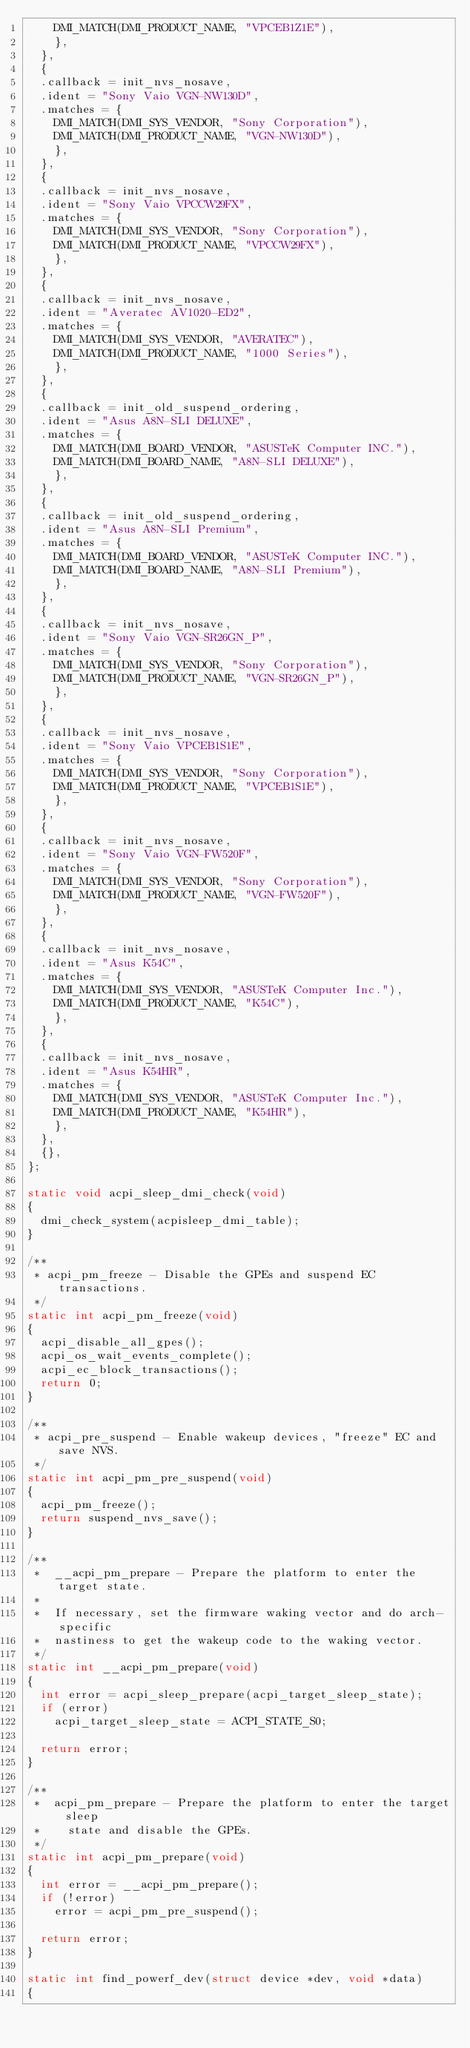Convert code to text. <code><loc_0><loc_0><loc_500><loc_500><_C_>		DMI_MATCH(DMI_PRODUCT_NAME, "VPCEB1Z1E"),
		},
	},
	{
	.callback = init_nvs_nosave,
	.ident = "Sony Vaio VGN-NW130D",
	.matches = {
		DMI_MATCH(DMI_SYS_VENDOR, "Sony Corporation"),
		DMI_MATCH(DMI_PRODUCT_NAME, "VGN-NW130D"),
		},
	},
	{
	.callback = init_nvs_nosave,
	.ident = "Sony Vaio VPCCW29FX",
	.matches = {
		DMI_MATCH(DMI_SYS_VENDOR, "Sony Corporation"),
		DMI_MATCH(DMI_PRODUCT_NAME, "VPCCW29FX"),
		},
	},
	{
	.callback = init_nvs_nosave,
	.ident = "Averatec AV1020-ED2",
	.matches = {
		DMI_MATCH(DMI_SYS_VENDOR, "AVERATEC"),
		DMI_MATCH(DMI_PRODUCT_NAME, "1000 Series"),
		},
	},
	{
	.callback = init_old_suspend_ordering,
	.ident = "Asus A8N-SLI DELUXE",
	.matches = {
		DMI_MATCH(DMI_BOARD_VENDOR, "ASUSTeK Computer INC."),
		DMI_MATCH(DMI_BOARD_NAME, "A8N-SLI DELUXE"),
		},
	},
	{
	.callback = init_old_suspend_ordering,
	.ident = "Asus A8N-SLI Premium",
	.matches = {
		DMI_MATCH(DMI_BOARD_VENDOR, "ASUSTeK Computer INC."),
		DMI_MATCH(DMI_BOARD_NAME, "A8N-SLI Premium"),
		},
	},
	{
	.callback = init_nvs_nosave,
	.ident = "Sony Vaio VGN-SR26GN_P",
	.matches = {
		DMI_MATCH(DMI_SYS_VENDOR, "Sony Corporation"),
		DMI_MATCH(DMI_PRODUCT_NAME, "VGN-SR26GN_P"),
		},
	},
	{
	.callback = init_nvs_nosave,
	.ident = "Sony Vaio VPCEB1S1E",
	.matches = {
		DMI_MATCH(DMI_SYS_VENDOR, "Sony Corporation"),
		DMI_MATCH(DMI_PRODUCT_NAME, "VPCEB1S1E"),
		},
	},
	{
	.callback = init_nvs_nosave,
	.ident = "Sony Vaio VGN-FW520F",
	.matches = {
		DMI_MATCH(DMI_SYS_VENDOR, "Sony Corporation"),
		DMI_MATCH(DMI_PRODUCT_NAME, "VGN-FW520F"),
		},
	},
	{
	.callback = init_nvs_nosave,
	.ident = "Asus K54C",
	.matches = {
		DMI_MATCH(DMI_SYS_VENDOR, "ASUSTeK Computer Inc."),
		DMI_MATCH(DMI_PRODUCT_NAME, "K54C"),
		},
	},
	{
	.callback = init_nvs_nosave,
	.ident = "Asus K54HR",
	.matches = {
		DMI_MATCH(DMI_SYS_VENDOR, "ASUSTeK Computer Inc."),
		DMI_MATCH(DMI_PRODUCT_NAME, "K54HR"),
		},
	},
	{},
};

static void acpi_sleep_dmi_check(void)
{
	dmi_check_system(acpisleep_dmi_table);
}

/**
 * acpi_pm_freeze - Disable the GPEs and suspend EC transactions.
 */
static int acpi_pm_freeze(void)
{
	acpi_disable_all_gpes();
	acpi_os_wait_events_complete();
	acpi_ec_block_transactions();
	return 0;
}

/**
 * acpi_pre_suspend - Enable wakeup devices, "freeze" EC and save NVS.
 */
static int acpi_pm_pre_suspend(void)
{
	acpi_pm_freeze();
	return suspend_nvs_save();
}

/**
 *	__acpi_pm_prepare - Prepare the platform to enter the target state.
 *
 *	If necessary, set the firmware waking vector and do arch-specific
 *	nastiness to get the wakeup code to the waking vector.
 */
static int __acpi_pm_prepare(void)
{
	int error = acpi_sleep_prepare(acpi_target_sleep_state);
	if (error)
		acpi_target_sleep_state = ACPI_STATE_S0;

	return error;
}

/**
 *	acpi_pm_prepare - Prepare the platform to enter the target sleep
 *		state and disable the GPEs.
 */
static int acpi_pm_prepare(void)
{
	int error = __acpi_pm_prepare();
	if (!error)
		error = acpi_pm_pre_suspend();

	return error;
}

static int find_powerf_dev(struct device *dev, void *data)
{</code> 